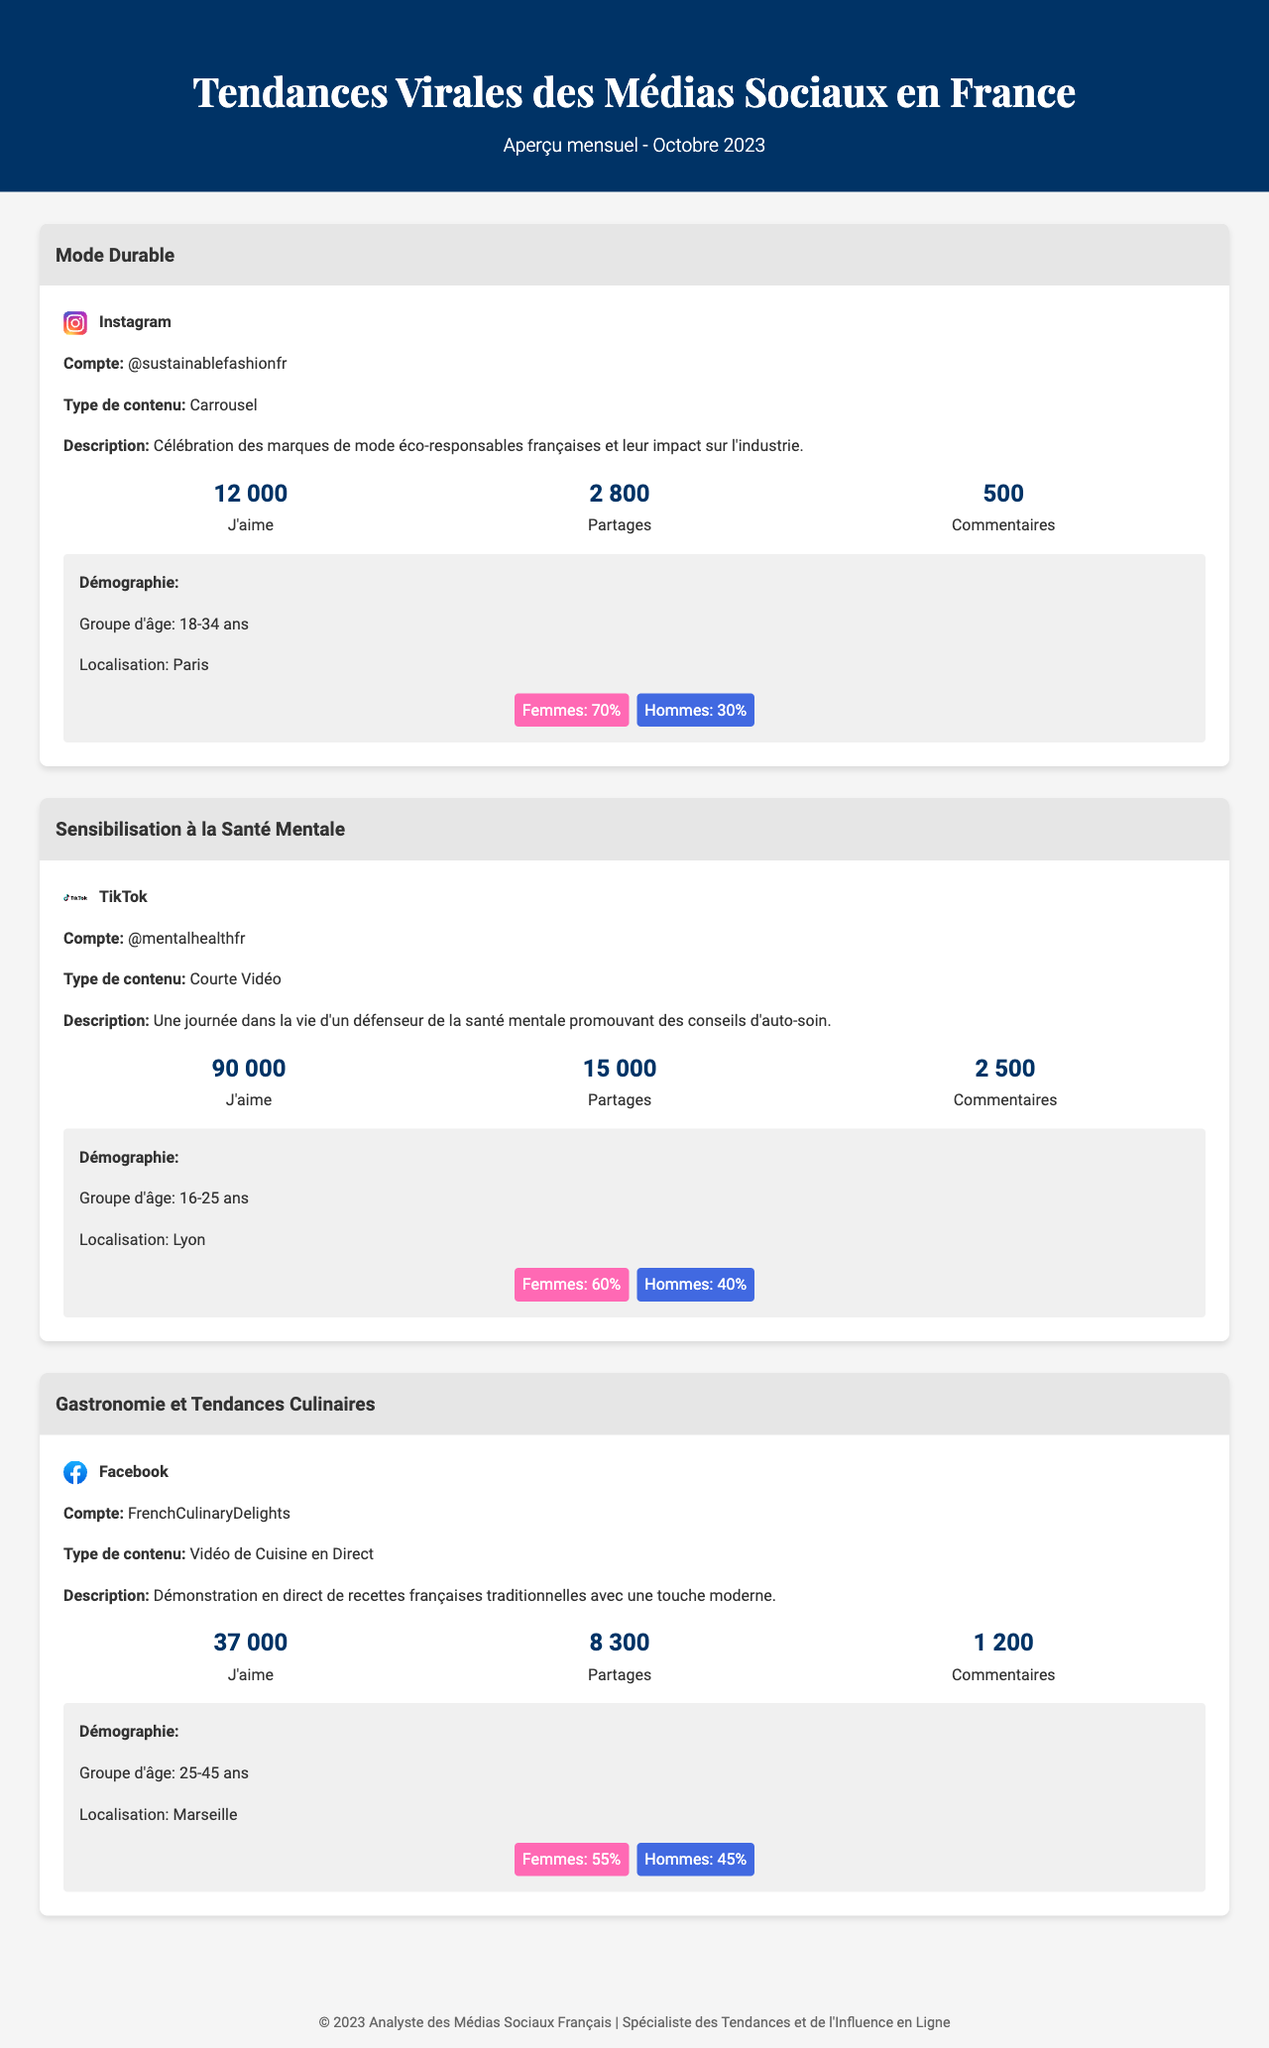What is the most liked content this month? The most liked content is from the TikTok account @mentalhealthfr with 90,000 likes.
Answer: 90 000 What percentage of the audience for @sustainablefashionfr are women? The gender distribution for @sustainablefashionfr indicates that 70% of the audience are women.
Answer: 70% What is the content type for the Facebook account FrenchCulinaryDelights? The content type for the Facebook account FrenchCulinaryDelights is "Vidéo de Cuisine en Direct."
Answer: Vidéo de Cuisine en Direct What city is associated with the TikTok account @mentalhealthfr? The TikTok account @mentalhealthfr is associated with Lyon.
Answer: Lyon How many comments did the Instagram content about Mode Durable receive? The Instagram content about Mode Durable received 500 comments.
Answer: 500 Which platform has the highest share count in this overview? The TikTok content has the highest share count of 15,000 shares.
Answer: 15 000 What demographic group engages most with the content on FrenchCulinaryDelights? The demographic group that engages most with the content on FrenchCulinaryDelights is aged 25-45 years.
Answer: 25-45 ans What is the name of the account that posted about Sensibilisation à la Santé Mentale? The account that posted about Sensibilisation à la Santé Mentale is @mentalhealthfr.
Answer: @mentalhealthfr What is the total engagement count (likes, shares, and comments) for the Mode Durable content? The total engagement for Mode Durable is calculated as 12,000 likes + 2,800 shares + 500 comments = 15,300.
Answer: 15 300 